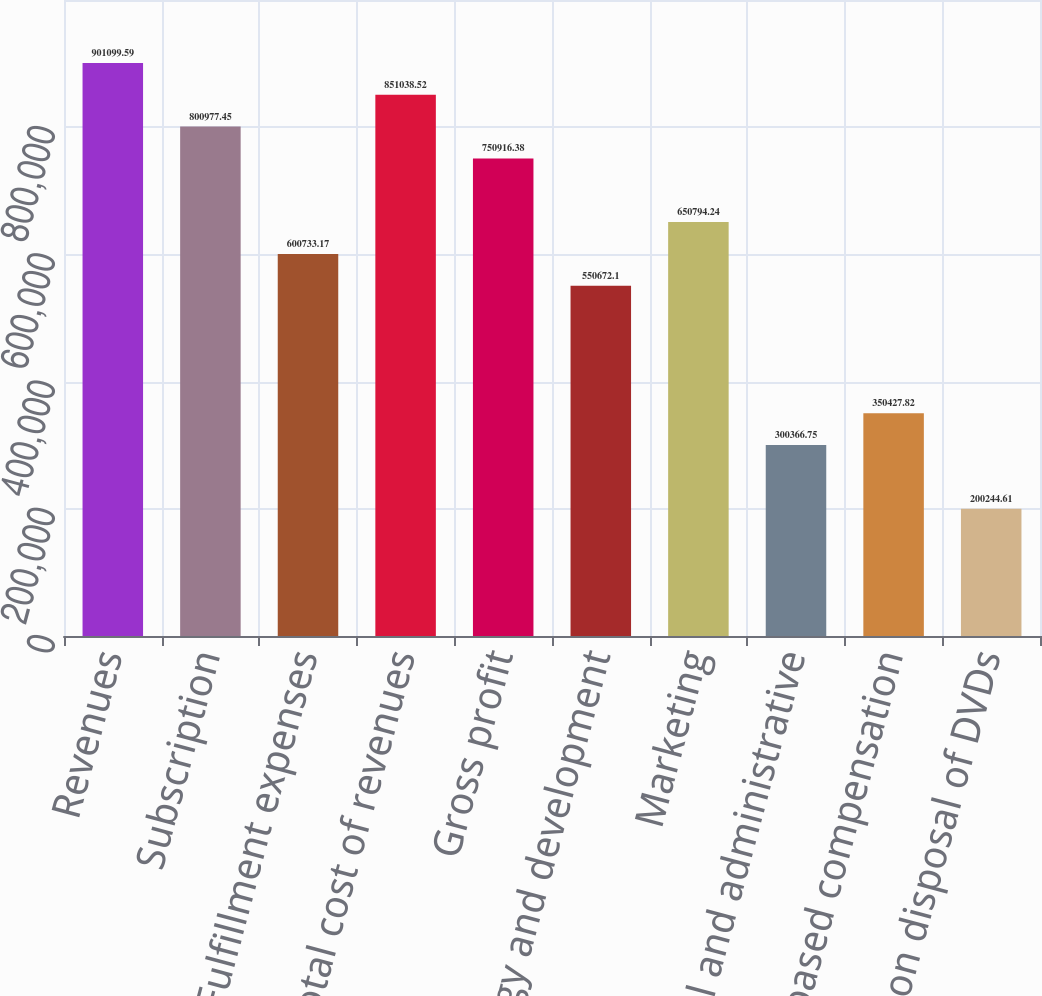<chart> <loc_0><loc_0><loc_500><loc_500><bar_chart><fcel>Revenues<fcel>Subscription<fcel>Fulfillment expenses<fcel>Total cost of revenues<fcel>Gross profit<fcel>Technology and development<fcel>Marketing<fcel>General and administrative<fcel>Stock-based compensation<fcel>Gain on disposal of DVDs<nl><fcel>901100<fcel>800977<fcel>600733<fcel>851039<fcel>750916<fcel>550672<fcel>650794<fcel>300367<fcel>350428<fcel>200245<nl></chart> 